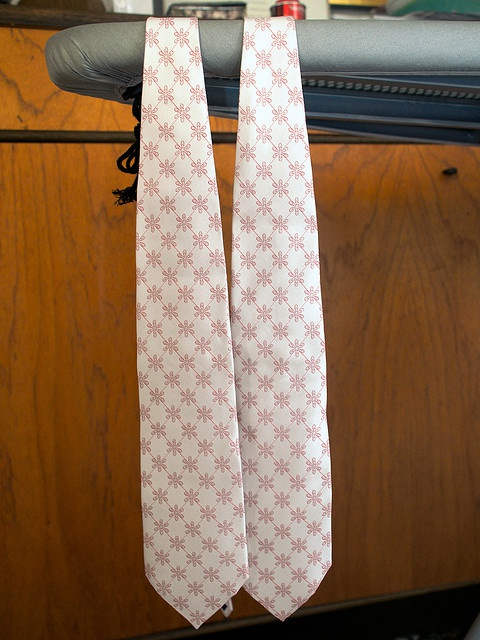Describe the objects in this image and their specific colors. I can see a tie in black, lightgray, and darkgray tones in this image. 